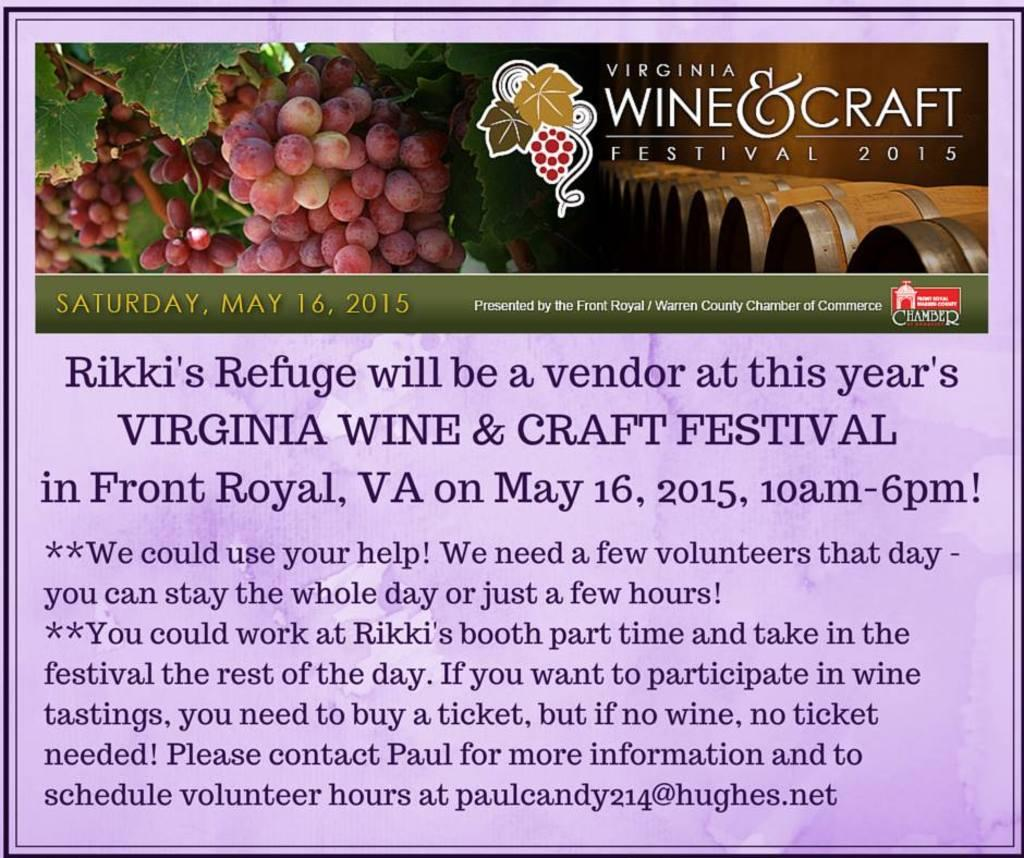What type of image might this be? The image might be a poster. What type of fruit is depicted in the image? There are grapes depicted in the image. What other elements are present in the image besides grapes? There are leaves and barrels depicted in the image. Is there any text present in the image? Yes, there is text at the top and bottom of the image. How does the writer contribute to pollution in the image? There is no writer or pollution present in the image. What type of roll is depicted in the image? There is no roll depicted in the image. 